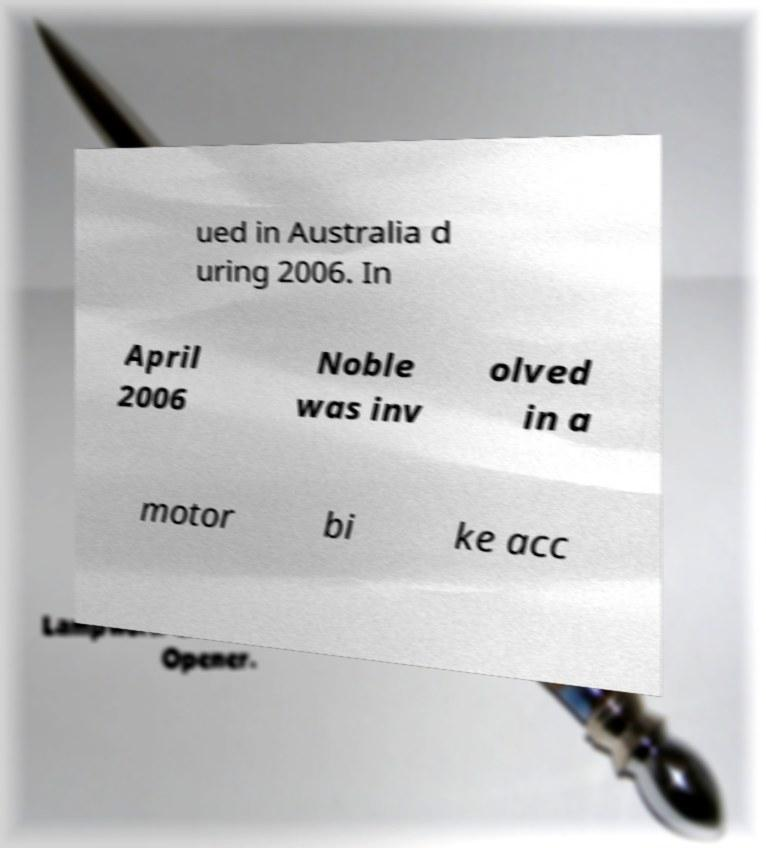Could you assist in decoding the text presented in this image and type it out clearly? ued in Australia d uring 2006. In April 2006 Noble was inv olved in a motor bi ke acc 